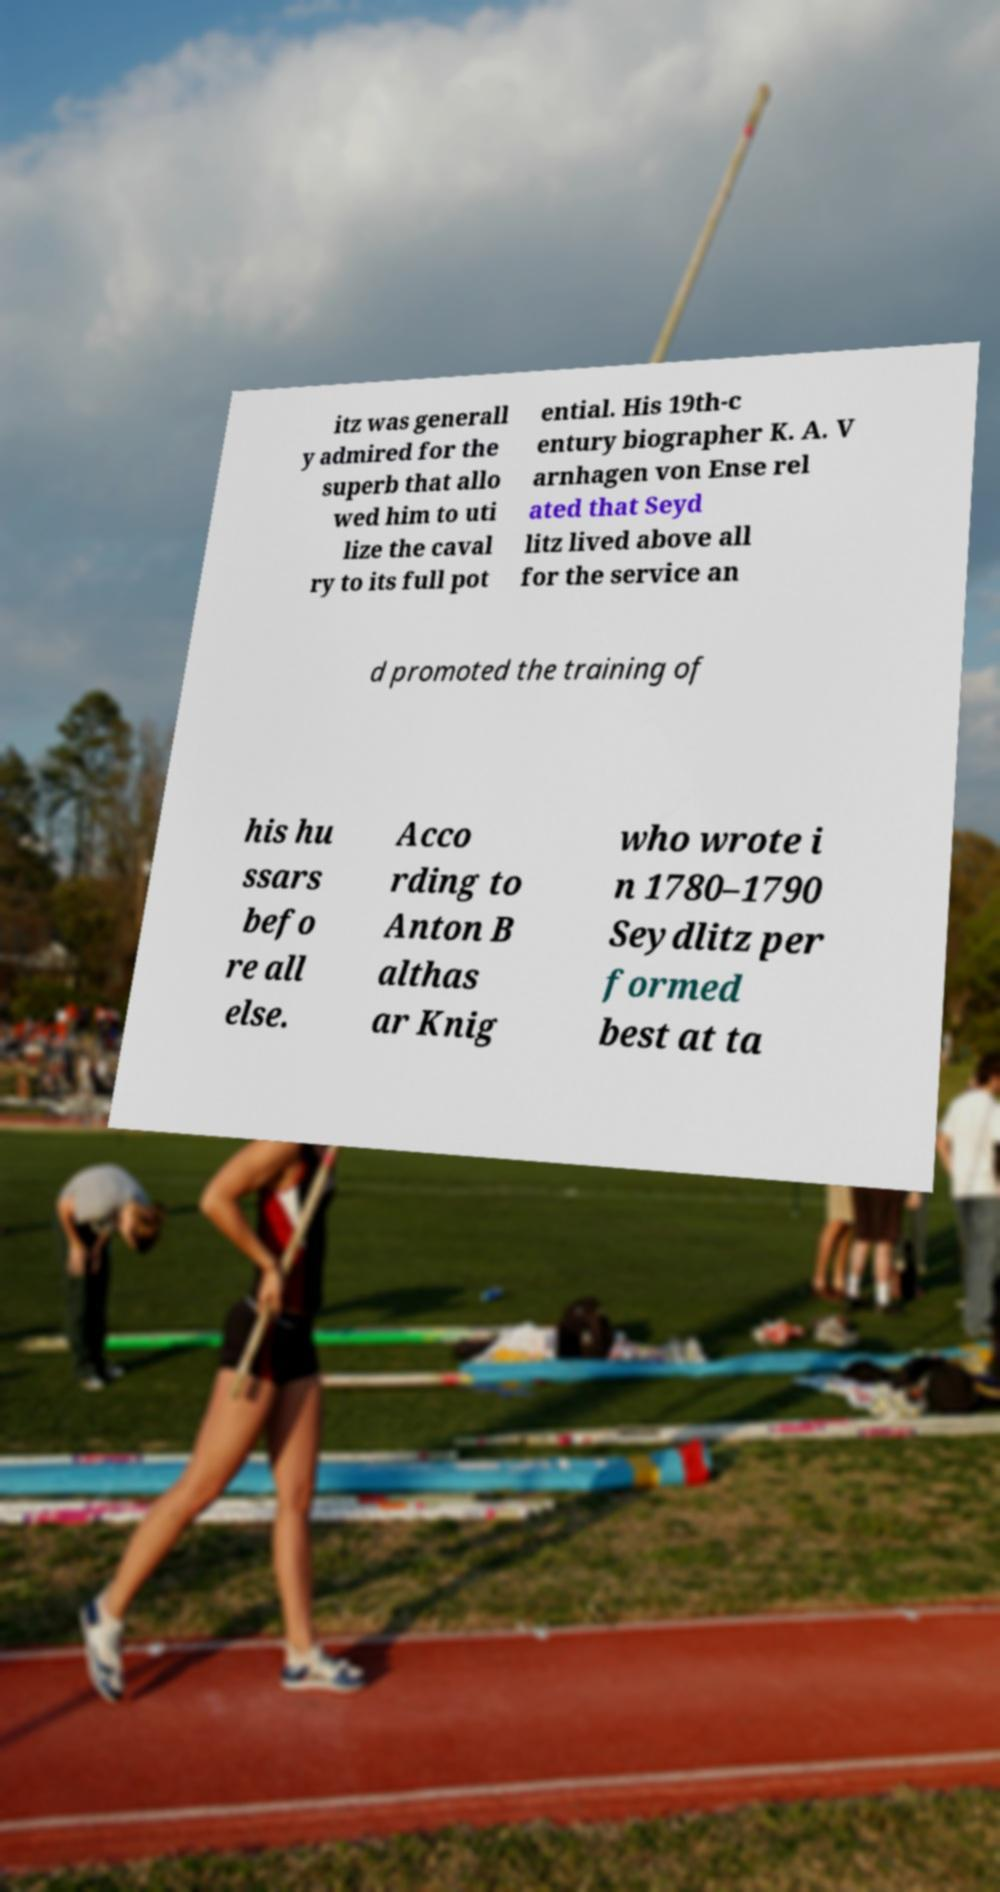Can you read and provide the text displayed in the image?This photo seems to have some interesting text. Can you extract and type it out for me? itz was generall y admired for the superb that allo wed him to uti lize the caval ry to its full pot ential. His 19th-c entury biographer K. A. V arnhagen von Ense rel ated that Seyd litz lived above all for the service an d promoted the training of his hu ssars befo re all else. Acco rding to Anton B althas ar Knig who wrote i n 1780–1790 Seydlitz per formed best at ta 